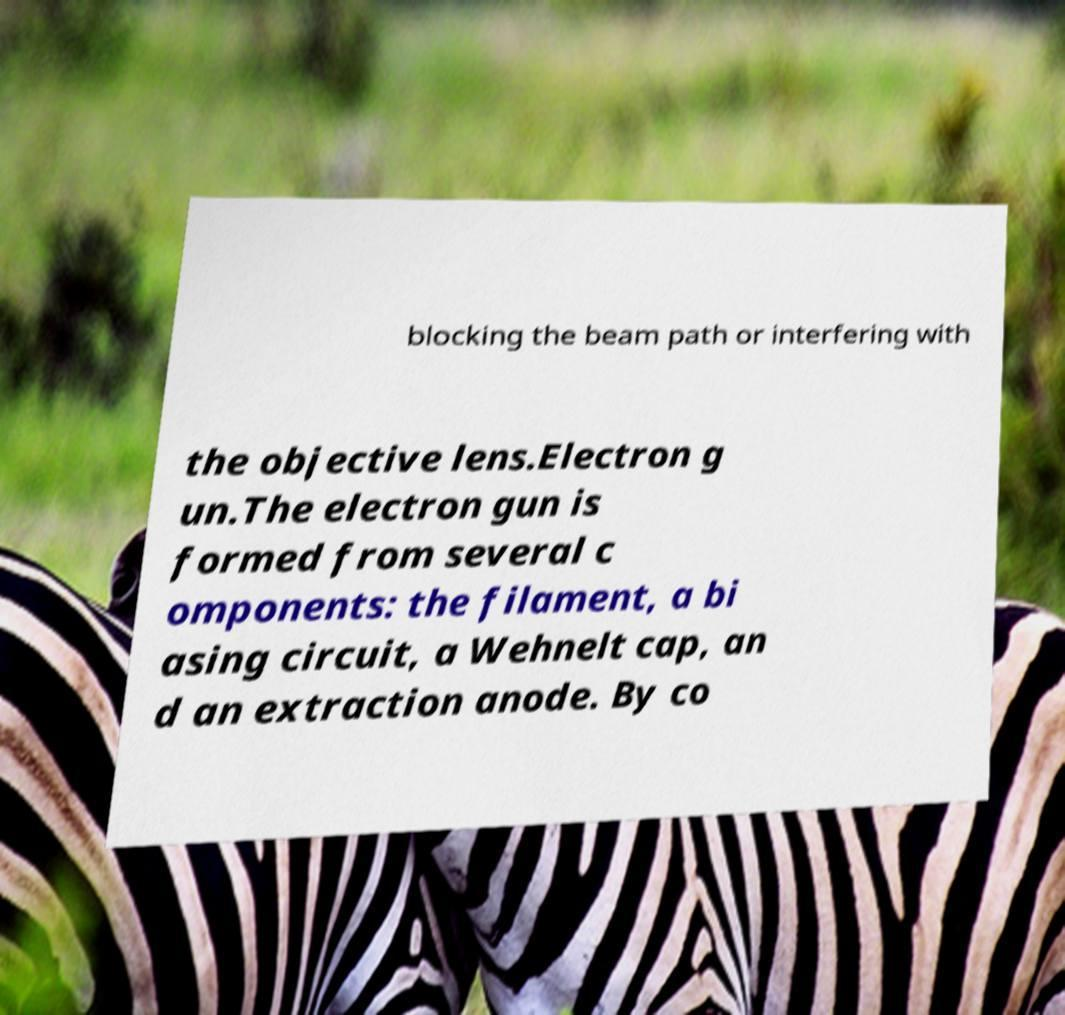Please identify and transcribe the text found in this image. blocking the beam path or interfering with the objective lens.Electron g un.The electron gun is formed from several c omponents: the filament, a bi asing circuit, a Wehnelt cap, an d an extraction anode. By co 